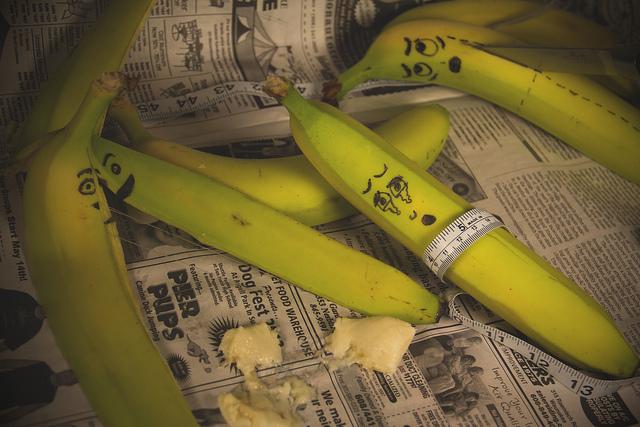What is depicted on the bananas?
Short answer required. Faces. What does the ad next to the sliced banana say?
Short answer required. Pier pups. Are the bananas bruised?
Be succinct. No. 